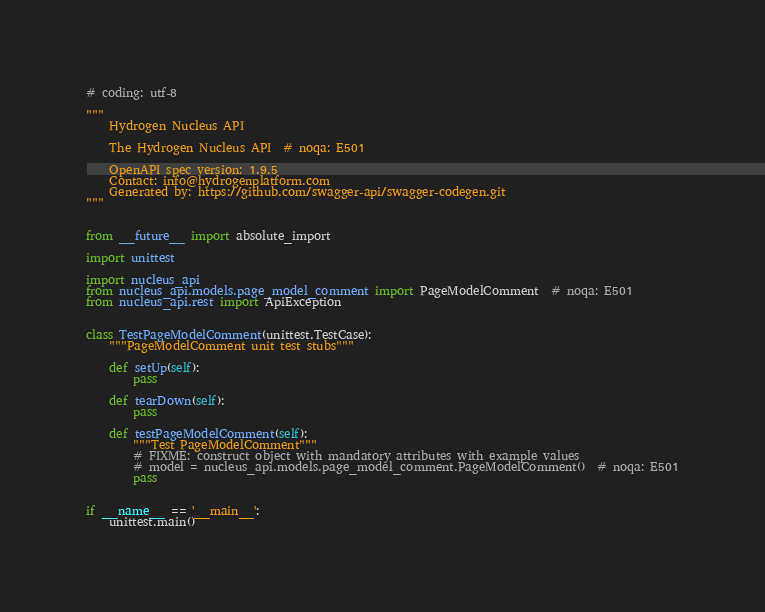Convert code to text. <code><loc_0><loc_0><loc_500><loc_500><_Python_># coding: utf-8

"""
    Hydrogen Nucleus API

    The Hydrogen Nucleus API  # noqa: E501

    OpenAPI spec version: 1.9.5
    Contact: info@hydrogenplatform.com
    Generated by: https://github.com/swagger-api/swagger-codegen.git
"""


from __future__ import absolute_import

import unittest

import nucleus_api
from nucleus_api.models.page_model_comment import PageModelComment  # noqa: E501
from nucleus_api.rest import ApiException


class TestPageModelComment(unittest.TestCase):
    """PageModelComment unit test stubs"""

    def setUp(self):
        pass

    def tearDown(self):
        pass

    def testPageModelComment(self):
        """Test PageModelComment"""
        # FIXME: construct object with mandatory attributes with example values
        # model = nucleus_api.models.page_model_comment.PageModelComment()  # noqa: E501
        pass


if __name__ == '__main__':
    unittest.main()
</code> 